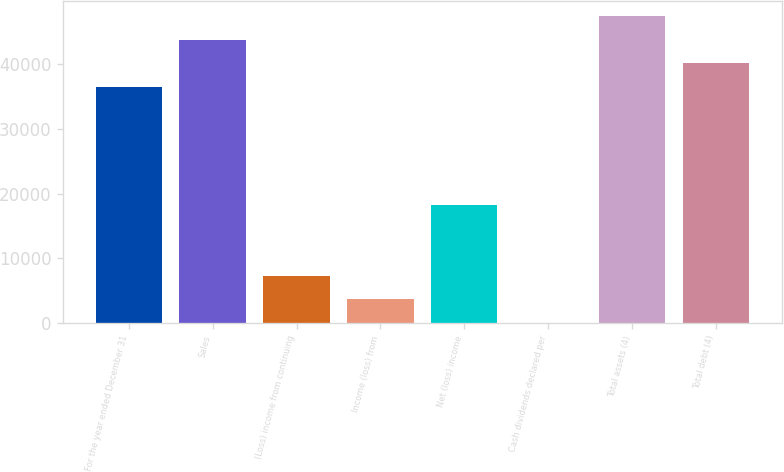Convert chart. <chart><loc_0><loc_0><loc_500><loc_500><bar_chart><fcel>For the year ended December 31<fcel>Sales<fcel>(Loss) income from continuing<fcel>Income (loss) from<fcel>Net (loss) income<fcel>Cash dividends declared per<fcel>Total assets (4)<fcel>Total debt (4)<nl><fcel>36477<fcel>43772.3<fcel>7295.68<fcel>3648.02<fcel>18238.7<fcel>0.36<fcel>47419.9<fcel>40124.6<nl></chart> 